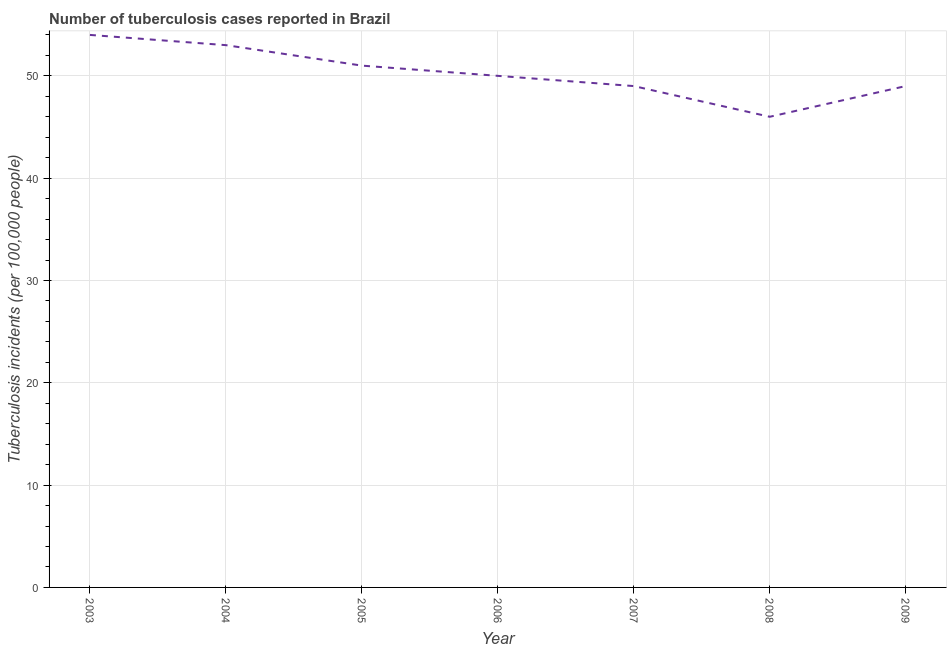What is the number of tuberculosis incidents in 2005?
Ensure brevity in your answer.  51. Across all years, what is the maximum number of tuberculosis incidents?
Keep it short and to the point. 54. Across all years, what is the minimum number of tuberculosis incidents?
Provide a short and direct response. 46. In which year was the number of tuberculosis incidents maximum?
Your answer should be compact. 2003. In which year was the number of tuberculosis incidents minimum?
Provide a short and direct response. 2008. What is the sum of the number of tuberculosis incidents?
Give a very brief answer. 352. What is the difference between the number of tuberculosis incidents in 2008 and 2009?
Give a very brief answer. -3. What is the average number of tuberculosis incidents per year?
Offer a very short reply. 50.29. In how many years, is the number of tuberculosis incidents greater than 12 ?
Provide a short and direct response. 7. What is the ratio of the number of tuberculosis incidents in 2006 to that in 2008?
Give a very brief answer. 1.09. Is the number of tuberculosis incidents in 2005 less than that in 2008?
Give a very brief answer. No. Is the difference between the number of tuberculosis incidents in 2004 and 2009 greater than the difference between any two years?
Give a very brief answer. No. What is the difference between the highest and the second highest number of tuberculosis incidents?
Keep it short and to the point. 1. What is the difference between the highest and the lowest number of tuberculosis incidents?
Ensure brevity in your answer.  8. In how many years, is the number of tuberculosis incidents greater than the average number of tuberculosis incidents taken over all years?
Your answer should be compact. 3. Does the number of tuberculosis incidents monotonically increase over the years?
Keep it short and to the point. No. How many lines are there?
Your answer should be compact. 1. What is the difference between two consecutive major ticks on the Y-axis?
Offer a very short reply. 10. Does the graph contain grids?
Provide a short and direct response. Yes. What is the title of the graph?
Give a very brief answer. Number of tuberculosis cases reported in Brazil. What is the label or title of the X-axis?
Make the answer very short. Year. What is the label or title of the Y-axis?
Provide a short and direct response. Tuberculosis incidents (per 100,0 people). What is the Tuberculosis incidents (per 100,000 people) in 2003?
Ensure brevity in your answer.  54. What is the Tuberculosis incidents (per 100,000 people) in 2005?
Offer a terse response. 51. What is the Tuberculosis incidents (per 100,000 people) in 2007?
Offer a terse response. 49. What is the Tuberculosis incidents (per 100,000 people) of 2009?
Make the answer very short. 49. What is the difference between the Tuberculosis incidents (per 100,000 people) in 2003 and 2006?
Provide a short and direct response. 4. What is the difference between the Tuberculosis incidents (per 100,000 people) in 2003 and 2008?
Your response must be concise. 8. What is the difference between the Tuberculosis incidents (per 100,000 people) in 2005 and 2006?
Provide a short and direct response. 1. What is the difference between the Tuberculosis incidents (per 100,000 people) in 2005 and 2007?
Make the answer very short. 2. What is the difference between the Tuberculosis incidents (per 100,000 people) in 2006 and 2009?
Keep it short and to the point. 1. What is the difference between the Tuberculosis incidents (per 100,000 people) in 2008 and 2009?
Provide a succinct answer. -3. What is the ratio of the Tuberculosis incidents (per 100,000 people) in 2003 to that in 2005?
Give a very brief answer. 1.06. What is the ratio of the Tuberculosis incidents (per 100,000 people) in 2003 to that in 2006?
Ensure brevity in your answer.  1.08. What is the ratio of the Tuberculosis incidents (per 100,000 people) in 2003 to that in 2007?
Keep it short and to the point. 1.1. What is the ratio of the Tuberculosis incidents (per 100,000 people) in 2003 to that in 2008?
Offer a very short reply. 1.17. What is the ratio of the Tuberculosis incidents (per 100,000 people) in 2003 to that in 2009?
Keep it short and to the point. 1.1. What is the ratio of the Tuberculosis incidents (per 100,000 people) in 2004 to that in 2005?
Offer a very short reply. 1.04. What is the ratio of the Tuberculosis incidents (per 100,000 people) in 2004 to that in 2006?
Offer a terse response. 1.06. What is the ratio of the Tuberculosis incidents (per 100,000 people) in 2004 to that in 2007?
Make the answer very short. 1.08. What is the ratio of the Tuberculosis incidents (per 100,000 people) in 2004 to that in 2008?
Offer a very short reply. 1.15. What is the ratio of the Tuberculosis incidents (per 100,000 people) in 2004 to that in 2009?
Offer a very short reply. 1.08. What is the ratio of the Tuberculosis incidents (per 100,000 people) in 2005 to that in 2006?
Keep it short and to the point. 1.02. What is the ratio of the Tuberculosis incidents (per 100,000 people) in 2005 to that in 2007?
Provide a short and direct response. 1.04. What is the ratio of the Tuberculosis incidents (per 100,000 people) in 2005 to that in 2008?
Give a very brief answer. 1.11. What is the ratio of the Tuberculosis incidents (per 100,000 people) in 2005 to that in 2009?
Make the answer very short. 1.04. What is the ratio of the Tuberculosis incidents (per 100,000 people) in 2006 to that in 2008?
Provide a succinct answer. 1.09. What is the ratio of the Tuberculosis incidents (per 100,000 people) in 2006 to that in 2009?
Keep it short and to the point. 1.02. What is the ratio of the Tuberculosis incidents (per 100,000 people) in 2007 to that in 2008?
Give a very brief answer. 1.06. What is the ratio of the Tuberculosis incidents (per 100,000 people) in 2008 to that in 2009?
Offer a terse response. 0.94. 